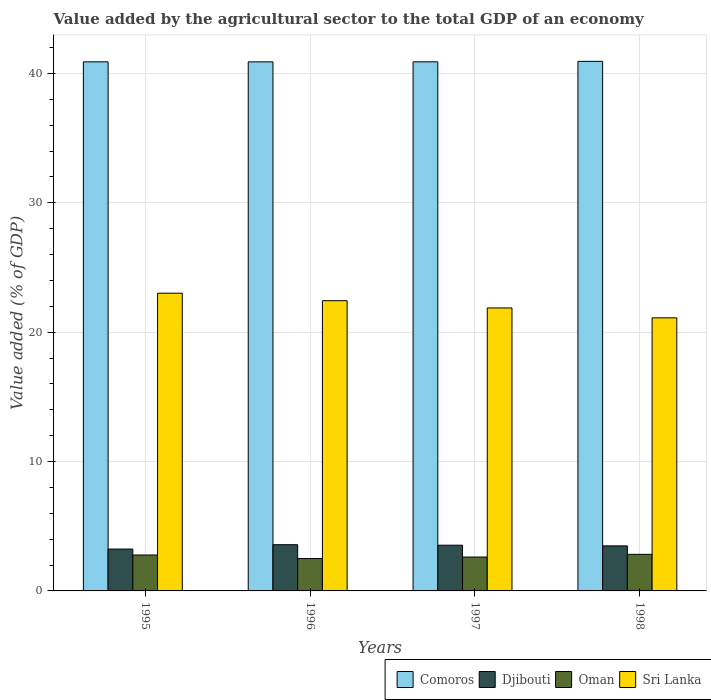How many groups of bars are there?
Keep it short and to the point. 4. Are the number of bars per tick equal to the number of legend labels?
Provide a short and direct response. Yes. How many bars are there on the 2nd tick from the right?
Offer a terse response. 4. What is the value added by the agricultural sector to the total GDP in Sri Lanka in 1995?
Offer a terse response. 23.01. Across all years, what is the maximum value added by the agricultural sector to the total GDP in Comoros?
Provide a succinct answer. 40.93. Across all years, what is the minimum value added by the agricultural sector to the total GDP in Djibouti?
Offer a terse response. 3.24. What is the total value added by the agricultural sector to the total GDP in Oman in the graph?
Provide a succinct answer. 10.73. What is the difference between the value added by the agricultural sector to the total GDP in Sri Lanka in 1995 and that in 1996?
Give a very brief answer. 0.58. What is the difference between the value added by the agricultural sector to the total GDP in Sri Lanka in 1998 and the value added by the agricultural sector to the total GDP in Comoros in 1995?
Make the answer very short. -19.79. What is the average value added by the agricultural sector to the total GDP in Djibouti per year?
Provide a succinct answer. 3.46. In the year 1996, what is the difference between the value added by the agricultural sector to the total GDP in Oman and value added by the agricultural sector to the total GDP in Djibouti?
Make the answer very short. -1.07. In how many years, is the value added by the agricultural sector to the total GDP in Djibouti greater than 24 %?
Provide a short and direct response. 0. What is the ratio of the value added by the agricultural sector to the total GDP in Sri Lanka in 1995 to that in 1998?
Offer a terse response. 1.09. What is the difference between the highest and the second highest value added by the agricultural sector to the total GDP in Oman?
Offer a terse response. 0.05. What is the difference between the highest and the lowest value added by the agricultural sector to the total GDP in Sri Lanka?
Make the answer very short. 1.9. In how many years, is the value added by the agricultural sector to the total GDP in Sri Lanka greater than the average value added by the agricultural sector to the total GDP in Sri Lanka taken over all years?
Your answer should be very brief. 2. What does the 1st bar from the left in 1995 represents?
Your response must be concise. Comoros. What does the 1st bar from the right in 1998 represents?
Make the answer very short. Sri Lanka. Is it the case that in every year, the sum of the value added by the agricultural sector to the total GDP in Oman and value added by the agricultural sector to the total GDP in Sri Lanka is greater than the value added by the agricultural sector to the total GDP in Djibouti?
Provide a succinct answer. Yes. How many bars are there?
Your answer should be very brief. 16. How many years are there in the graph?
Your answer should be very brief. 4. What is the difference between two consecutive major ticks on the Y-axis?
Offer a terse response. 10. Does the graph contain grids?
Your response must be concise. Yes. Where does the legend appear in the graph?
Offer a terse response. Bottom right. How many legend labels are there?
Your response must be concise. 4. What is the title of the graph?
Your answer should be compact. Value added by the agricultural sector to the total GDP of an economy. What is the label or title of the Y-axis?
Keep it short and to the point. Value added (% of GDP). What is the Value added (% of GDP) in Comoros in 1995?
Provide a succinct answer. 40.89. What is the Value added (% of GDP) of Djibouti in 1995?
Keep it short and to the point. 3.24. What is the Value added (% of GDP) in Oman in 1995?
Make the answer very short. 2.78. What is the Value added (% of GDP) of Sri Lanka in 1995?
Your answer should be very brief. 23.01. What is the Value added (% of GDP) in Comoros in 1996?
Provide a succinct answer. 40.89. What is the Value added (% of GDP) in Djibouti in 1996?
Offer a terse response. 3.57. What is the Value added (% of GDP) of Oman in 1996?
Give a very brief answer. 2.5. What is the Value added (% of GDP) of Sri Lanka in 1996?
Provide a short and direct response. 22.43. What is the Value added (% of GDP) of Comoros in 1997?
Your answer should be compact. 40.89. What is the Value added (% of GDP) in Djibouti in 1997?
Keep it short and to the point. 3.53. What is the Value added (% of GDP) in Oman in 1997?
Keep it short and to the point. 2.62. What is the Value added (% of GDP) of Sri Lanka in 1997?
Your answer should be very brief. 21.87. What is the Value added (% of GDP) in Comoros in 1998?
Your response must be concise. 40.93. What is the Value added (% of GDP) of Djibouti in 1998?
Your answer should be very brief. 3.48. What is the Value added (% of GDP) of Oman in 1998?
Offer a very short reply. 2.83. What is the Value added (% of GDP) of Sri Lanka in 1998?
Your response must be concise. 21.11. Across all years, what is the maximum Value added (% of GDP) of Comoros?
Ensure brevity in your answer.  40.93. Across all years, what is the maximum Value added (% of GDP) of Djibouti?
Your answer should be very brief. 3.57. Across all years, what is the maximum Value added (% of GDP) of Oman?
Your answer should be very brief. 2.83. Across all years, what is the maximum Value added (% of GDP) in Sri Lanka?
Provide a short and direct response. 23.01. Across all years, what is the minimum Value added (% of GDP) of Comoros?
Your answer should be very brief. 40.89. Across all years, what is the minimum Value added (% of GDP) in Djibouti?
Give a very brief answer. 3.24. Across all years, what is the minimum Value added (% of GDP) of Oman?
Provide a short and direct response. 2.5. Across all years, what is the minimum Value added (% of GDP) in Sri Lanka?
Provide a succinct answer. 21.11. What is the total Value added (% of GDP) of Comoros in the graph?
Provide a short and direct response. 163.61. What is the total Value added (% of GDP) in Djibouti in the graph?
Your answer should be very brief. 13.82. What is the total Value added (% of GDP) in Oman in the graph?
Your answer should be very brief. 10.73. What is the total Value added (% of GDP) in Sri Lanka in the graph?
Give a very brief answer. 88.42. What is the difference between the Value added (% of GDP) of Comoros in 1995 and that in 1996?
Offer a terse response. 0. What is the difference between the Value added (% of GDP) of Djibouti in 1995 and that in 1996?
Make the answer very short. -0.34. What is the difference between the Value added (% of GDP) of Oman in 1995 and that in 1996?
Keep it short and to the point. 0.27. What is the difference between the Value added (% of GDP) in Sri Lanka in 1995 and that in 1996?
Ensure brevity in your answer.  0.58. What is the difference between the Value added (% of GDP) in Comoros in 1995 and that in 1997?
Offer a terse response. -0. What is the difference between the Value added (% of GDP) in Djibouti in 1995 and that in 1997?
Give a very brief answer. -0.3. What is the difference between the Value added (% of GDP) in Oman in 1995 and that in 1997?
Your answer should be very brief. 0.16. What is the difference between the Value added (% of GDP) in Sri Lanka in 1995 and that in 1997?
Your answer should be very brief. 1.14. What is the difference between the Value added (% of GDP) of Comoros in 1995 and that in 1998?
Offer a terse response. -0.04. What is the difference between the Value added (% of GDP) in Djibouti in 1995 and that in 1998?
Your response must be concise. -0.25. What is the difference between the Value added (% of GDP) of Oman in 1995 and that in 1998?
Keep it short and to the point. -0.05. What is the difference between the Value added (% of GDP) of Sri Lanka in 1995 and that in 1998?
Offer a very short reply. 1.9. What is the difference between the Value added (% of GDP) of Comoros in 1996 and that in 1997?
Your answer should be very brief. -0. What is the difference between the Value added (% of GDP) of Djibouti in 1996 and that in 1997?
Give a very brief answer. 0.04. What is the difference between the Value added (% of GDP) in Oman in 1996 and that in 1997?
Give a very brief answer. -0.12. What is the difference between the Value added (% of GDP) of Sri Lanka in 1996 and that in 1997?
Keep it short and to the point. 0.56. What is the difference between the Value added (% of GDP) of Comoros in 1996 and that in 1998?
Your response must be concise. -0.04. What is the difference between the Value added (% of GDP) in Djibouti in 1996 and that in 1998?
Keep it short and to the point. 0.09. What is the difference between the Value added (% of GDP) of Oman in 1996 and that in 1998?
Keep it short and to the point. -0.32. What is the difference between the Value added (% of GDP) of Sri Lanka in 1996 and that in 1998?
Offer a very short reply. 1.33. What is the difference between the Value added (% of GDP) in Comoros in 1997 and that in 1998?
Your answer should be very brief. -0.04. What is the difference between the Value added (% of GDP) in Djibouti in 1997 and that in 1998?
Give a very brief answer. 0.05. What is the difference between the Value added (% of GDP) of Oman in 1997 and that in 1998?
Offer a terse response. -0.21. What is the difference between the Value added (% of GDP) in Sri Lanka in 1997 and that in 1998?
Offer a very short reply. 0.76. What is the difference between the Value added (% of GDP) in Comoros in 1995 and the Value added (% of GDP) in Djibouti in 1996?
Provide a short and direct response. 37.32. What is the difference between the Value added (% of GDP) of Comoros in 1995 and the Value added (% of GDP) of Oman in 1996?
Provide a short and direct response. 38.39. What is the difference between the Value added (% of GDP) of Comoros in 1995 and the Value added (% of GDP) of Sri Lanka in 1996?
Offer a very short reply. 18.46. What is the difference between the Value added (% of GDP) in Djibouti in 1995 and the Value added (% of GDP) in Oman in 1996?
Provide a short and direct response. 0.73. What is the difference between the Value added (% of GDP) of Djibouti in 1995 and the Value added (% of GDP) of Sri Lanka in 1996?
Offer a very short reply. -19.2. What is the difference between the Value added (% of GDP) of Oman in 1995 and the Value added (% of GDP) of Sri Lanka in 1996?
Offer a very short reply. -19.66. What is the difference between the Value added (% of GDP) in Comoros in 1995 and the Value added (% of GDP) in Djibouti in 1997?
Give a very brief answer. 37.36. What is the difference between the Value added (% of GDP) of Comoros in 1995 and the Value added (% of GDP) of Oman in 1997?
Ensure brevity in your answer.  38.27. What is the difference between the Value added (% of GDP) in Comoros in 1995 and the Value added (% of GDP) in Sri Lanka in 1997?
Ensure brevity in your answer.  19.02. What is the difference between the Value added (% of GDP) of Djibouti in 1995 and the Value added (% of GDP) of Oman in 1997?
Offer a terse response. 0.62. What is the difference between the Value added (% of GDP) of Djibouti in 1995 and the Value added (% of GDP) of Sri Lanka in 1997?
Keep it short and to the point. -18.64. What is the difference between the Value added (% of GDP) in Oman in 1995 and the Value added (% of GDP) in Sri Lanka in 1997?
Your response must be concise. -19.1. What is the difference between the Value added (% of GDP) in Comoros in 1995 and the Value added (% of GDP) in Djibouti in 1998?
Your answer should be compact. 37.41. What is the difference between the Value added (% of GDP) in Comoros in 1995 and the Value added (% of GDP) in Oman in 1998?
Offer a terse response. 38.06. What is the difference between the Value added (% of GDP) in Comoros in 1995 and the Value added (% of GDP) in Sri Lanka in 1998?
Offer a very short reply. 19.79. What is the difference between the Value added (% of GDP) in Djibouti in 1995 and the Value added (% of GDP) in Oman in 1998?
Your answer should be compact. 0.41. What is the difference between the Value added (% of GDP) of Djibouti in 1995 and the Value added (% of GDP) of Sri Lanka in 1998?
Your response must be concise. -17.87. What is the difference between the Value added (% of GDP) of Oman in 1995 and the Value added (% of GDP) of Sri Lanka in 1998?
Offer a terse response. -18.33. What is the difference between the Value added (% of GDP) in Comoros in 1996 and the Value added (% of GDP) in Djibouti in 1997?
Offer a very short reply. 37.36. What is the difference between the Value added (% of GDP) of Comoros in 1996 and the Value added (% of GDP) of Oman in 1997?
Ensure brevity in your answer.  38.27. What is the difference between the Value added (% of GDP) of Comoros in 1996 and the Value added (% of GDP) of Sri Lanka in 1997?
Give a very brief answer. 19.02. What is the difference between the Value added (% of GDP) of Djibouti in 1996 and the Value added (% of GDP) of Oman in 1997?
Give a very brief answer. 0.95. What is the difference between the Value added (% of GDP) in Djibouti in 1996 and the Value added (% of GDP) in Sri Lanka in 1997?
Provide a succinct answer. -18.3. What is the difference between the Value added (% of GDP) of Oman in 1996 and the Value added (% of GDP) of Sri Lanka in 1997?
Your answer should be compact. -19.37. What is the difference between the Value added (% of GDP) in Comoros in 1996 and the Value added (% of GDP) in Djibouti in 1998?
Your answer should be very brief. 37.41. What is the difference between the Value added (% of GDP) of Comoros in 1996 and the Value added (% of GDP) of Oman in 1998?
Your response must be concise. 38.06. What is the difference between the Value added (% of GDP) of Comoros in 1996 and the Value added (% of GDP) of Sri Lanka in 1998?
Your answer should be compact. 19.79. What is the difference between the Value added (% of GDP) in Djibouti in 1996 and the Value added (% of GDP) in Oman in 1998?
Provide a succinct answer. 0.74. What is the difference between the Value added (% of GDP) in Djibouti in 1996 and the Value added (% of GDP) in Sri Lanka in 1998?
Offer a terse response. -17.53. What is the difference between the Value added (% of GDP) of Oman in 1996 and the Value added (% of GDP) of Sri Lanka in 1998?
Your answer should be compact. -18.6. What is the difference between the Value added (% of GDP) in Comoros in 1997 and the Value added (% of GDP) in Djibouti in 1998?
Offer a terse response. 37.41. What is the difference between the Value added (% of GDP) in Comoros in 1997 and the Value added (% of GDP) in Oman in 1998?
Provide a short and direct response. 38.06. What is the difference between the Value added (% of GDP) in Comoros in 1997 and the Value added (% of GDP) in Sri Lanka in 1998?
Your answer should be compact. 19.79. What is the difference between the Value added (% of GDP) of Djibouti in 1997 and the Value added (% of GDP) of Oman in 1998?
Your answer should be very brief. 0.7. What is the difference between the Value added (% of GDP) in Djibouti in 1997 and the Value added (% of GDP) in Sri Lanka in 1998?
Your response must be concise. -17.57. What is the difference between the Value added (% of GDP) of Oman in 1997 and the Value added (% of GDP) of Sri Lanka in 1998?
Your answer should be compact. -18.49. What is the average Value added (% of GDP) of Comoros per year?
Provide a short and direct response. 40.9. What is the average Value added (% of GDP) of Djibouti per year?
Your answer should be compact. 3.46. What is the average Value added (% of GDP) of Oman per year?
Offer a terse response. 2.68. What is the average Value added (% of GDP) of Sri Lanka per year?
Provide a short and direct response. 22.1. In the year 1995, what is the difference between the Value added (% of GDP) of Comoros and Value added (% of GDP) of Djibouti?
Offer a terse response. 37.66. In the year 1995, what is the difference between the Value added (% of GDP) of Comoros and Value added (% of GDP) of Oman?
Keep it short and to the point. 38.12. In the year 1995, what is the difference between the Value added (% of GDP) of Comoros and Value added (% of GDP) of Sri Lanka?
Offer a terse response. 17.88. In the year 1995, what is the difference between the Value added (% of GDP) in Djibouti and Value added (% of GDP) in Oman?
Offer a very short reply. 0.46. In the year 1995, what is the difference between the Value added (% of GDP) in Djibouti and Value added (% of GDP) in Sri Lanka?
Your answer should be compact. -19.78. In the year 1995, what is the difference between the Value added (% of GDP) of Oman and Value added (% of GDP) of Sri Lanka?
Offer a very short reply. -20.23. In the year 1996, what is the difference between the Value added (% of GDP) of Comoros and Value added (% of GDP) of Djibouti?
Give a very brief answer. 37.32. In the year 1996, what is the difference between the Value added (% of GDP) in Comoros and Value added (% of GDP) in Oman?
Your response must be concise. 38.39. In the year 1996, what is the difference between the Value added (% of GDP) of Comoros and Value added (% of GDP) of Sri Lanka?
Your answer should be very brief. 18.46. In the year 1996, what is the difference between the Value added (% of GDP) in Djibouti and Value added (% of GDP) in Oman?
Your response must be concise. 1.07. In the year 1996, what is the difference between the Value added (% of GDP) of Djibouti and Value added (% of GDP) of Sri Lanka?
Provide a succinct answer. -18.86. In the year 1996, what is the difference between the Value added (% of GDP) of Oman and Value added (% of GDP) of Sri Lanka?
Ensure brevity in your answer.  -19.93. In the year 1997, what is the difference between the Value added (% of GDP) of Comoros and Value added (% of GDP) of Djibouti?
Offer a terse response. 37.36. In the year 1997, what is the difference between the Value added (% of GDP) in Comoros and Value added (% of GDP) in Oman?
Your response must be concise. 38.27. In the year 1997, what is the difference between the Value added (% of GDP) in Comoros and Value added (% of GDP) in Sri Lanka?
Your response must be concise. 19.02. In the year 1997, what is the difference between the Value added (% of GDP) in Djibouti and Value added (% of GDP) in Oman?
Your answer should be very brief. 0.91. In the year 1997, what is the difference between the Value added (% of GDP) in Djibouti and Value added (% of GDP) in Sri Lanka?
Give a very brief answer. -18.34. In the year 1997, what is the difference between the Value added (% of GDP) of Oman and Value added (% of GDP) of Sri Lanka?
Your answer should be very brief. -19.25. In the year 1998, what is the difference between the Value added (% of GDP) of Comoros and Value added (% of GDP) of Djibouti?
Make the answer very short. 37.45. In the year 1998, what is the difference between the Value added (% of GDP) in Comoros and Value added (% of GDP) in Oman?
Provide a short and direct response. 38.1. In the year 1998, what is the difference between the Value added (% of GDP) of Comoros and Value added (% of GDP) of Sri Lanka?
Your response must be concise. 19.82. In the year 1998, what is the difference between the Value added (% of GDP) in Djibouti and Value added (% of GDP) in Oman?
Offer a very short reply. 0.65. In the year 1998, what is the difference between the Value added (% of GDP) in Djibouti and Value added (% of GDP) in Sri Lanka?
Your answer should be compact. -17.62. In the year 1998, what is the difference between the Value added (% of GDP) of Oman and Value added (% of GDP) of Sri Lanka?
Offer a very short reply. -18.28. What is the ratio of the Value added (% of GDP) in Djibouti in 1995 to that in 1996?
Offer a very short reply. 0.91. What is the ratio of the Value added (% of GDP) of Oman in 1995 to that in 1996?
Offer a terse response. 1.11. What is the ratio of the Value added (% of GDP) in Sri Lanka in 1995 to that in 1996?
Offer a terse response. 1.03. What is the ratio of the Value added (% of GDP) of Djibouti in 1995 to that in 1997?
Your response must be concise. 0.92. What is the ratio of the Value added (% of GDP) in Oman in 1995 to that in 1997?
Provide a succinct answer. 1.06. What is the ratio of the Value added (% of GDP) in Sri Lanka in 1995 to that in 1997?
Your answer should be very brief. 1.05. What is the ratio of the Value added (% of GDP) of Djibouti in 1995 to that in 1998?
Provide a succinct answer. 0.93. What is the ratio of the Value added (% of GDP) in Oman in 1995 to that in 1998?
Your response must be concise. 0.98. What is the ratio of the Value added (% of GDP) of Sri Lanka in 1995 to that in 1998?
Ensure brevity in your answer.  1.09. What is the ratio of the Value added (% of GDP) in Djibouti in 1996 to that in 1997?
Offer a very short reply. 1.01. What is the ratio of the Value added (% of GDP) in Oman in 1996 to that in 1997?
Your answer should be compact. 0.96. What is the ratio of the Value added (% of GDP) of Sri Lanka in 1996 to that in 1997?
Ensure brevity in your answer.  1.03. What is the ratio of the Value added (% of GDP) in Comoros in 1996 to that in 1998?
Your answer should be very brief. 1. What is the ratio of the Value added (% of GDP) of Djibouti in 1996 to that in 1998?
Offer a terse response. 1.03. What is the ratio of the Value added (% of GDP) in Oman in 1996 to that in 1998?
Offer a very short reply. 0.89. What is the ratio of the Value added (% of GDP) of Sri Lanka in 1996 to that in 1998?
Your response must be concise. 1.06. What is the ratio of the Value added (% of GDP) of Comoros in 1997 to that in 1998?
Your answer should be compact. 1. What is the ratio of the Value added (% of GDP) in Djibouti in 1997 to that in 1998?
Provide a short and direct response. 1.02. What is the ratio of the Value added (% of GDP) in Oman in 1997 to that in 1998?
Your answer should be compact. 0.93. What is the ratio of the Value added (% of GDP) of Sri Lanka in 1997 to that in 1998?
Your response must be concise. 1.04. What is the difference between the highest and the second highest Value added (% of GDP) of Comoros?
Your response must be concise. 0.04. What is the difference between the highest and the second highest Value added (% of GDP) in Djibouti?
Keep it short and to the point. 0.04. What is the difference between the highest and the second highest Value added (% of GDP) in Oman?
Provide a succinct answer. 0.05. What is the difference between the highest and the second highest Value added (% of GDP) in Sri Lanka?
Ensure brevity in your answer.  0.58. What is the difference between the highest and the lowest Value added (% of GDP) of Comoros?
Offer a terse response. 0.04. What is the difference between the highest and the lowest Value added (% of GDP) of Djibouti?
Make the answer very short. 0.34. What is the difference between the highest and the lowest Value added (% of GDP) in Oman?
Offer a terse response. 0.32. What is the difference between the highest and the lowest Value added (% of GDP) in Sri Lanka?
Offer a very short reply. 1.9. 